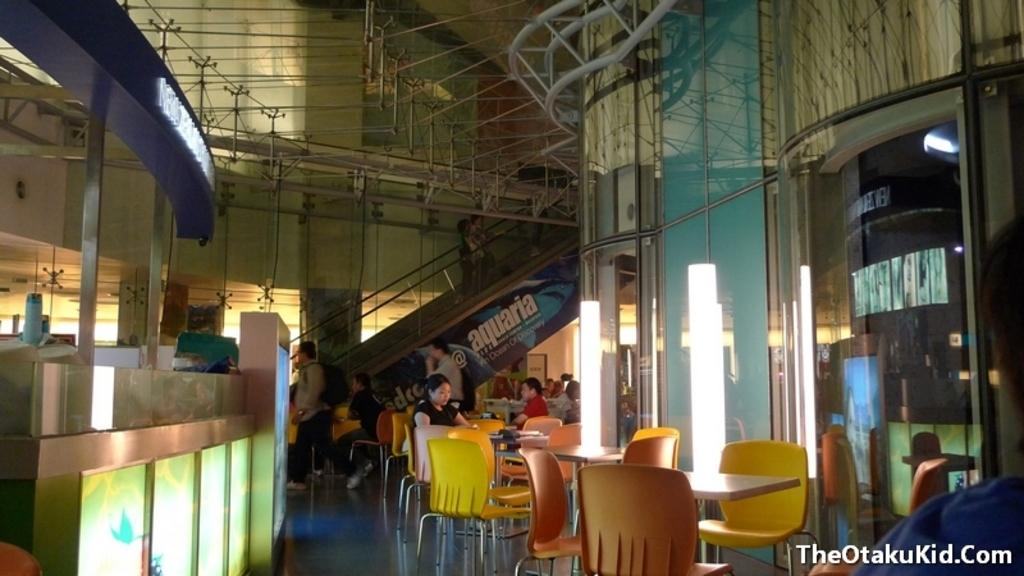How many people are in the image? There are people in the image, but the exact number is not specified. What type of furniture is present in the image? There are chairs and tables in the image. What type of material is used for the boards in the image? The material of the boards is not specified in the facts. What is the primary purpose of the glass in the image? The purpose of the glass is not specified in the facts. What are the rods used for in the image? The purpose of the rods is not specified in the facts. What type of surface is the floor made of in the image? The material of the floor is not specified in the facts. What kind of objects can be seen in the image? There are objects in the image, but their specific types are not specified. What type of train can be seen in the image? There is no train present in the image. What activity are the people engaged in while sitting on the chairs in the image? The specific activity of the people is not specified in the facts. 